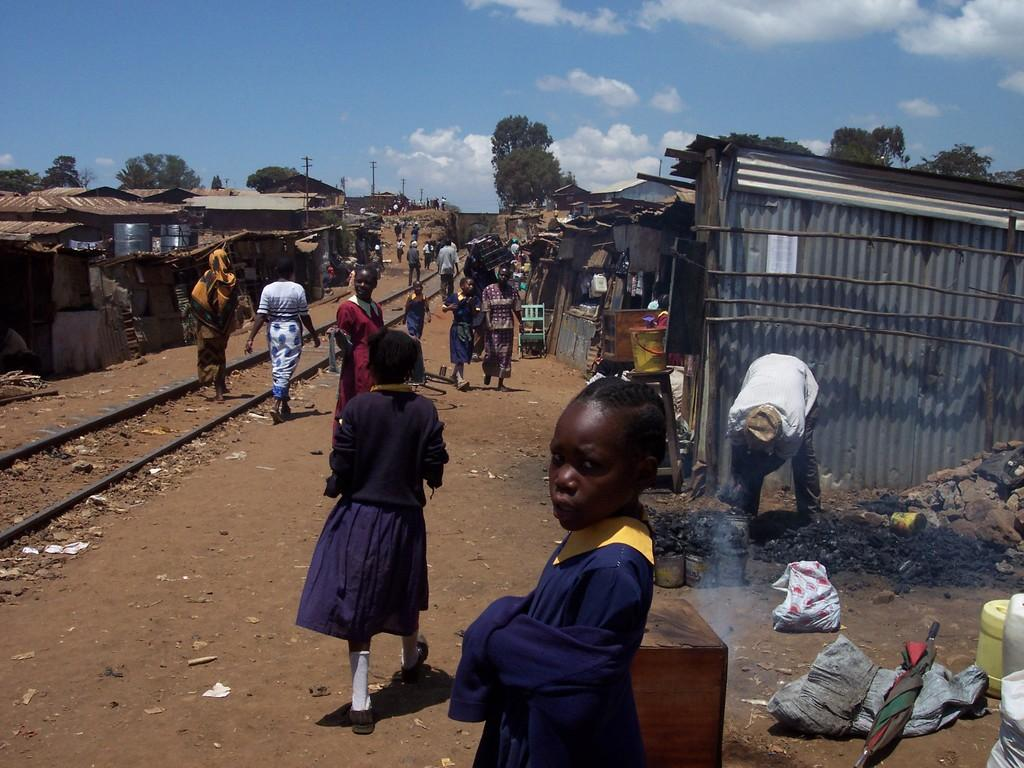What are the people in the image wearing? The persons in the image are wearing clothes. What structures can be seen on both sides of the image? There are sheds on both the left and right sides of the image. What can be seen in between the trees in the image? There is a track in between the trees in the image. What is visible in the sky in the image? There are clouds in the sky in the image. Can you tell me how many cubs are playing near the sheds in the image? There are no cubs present in the image; it features persons wearing clothes and sheds on both sides. 